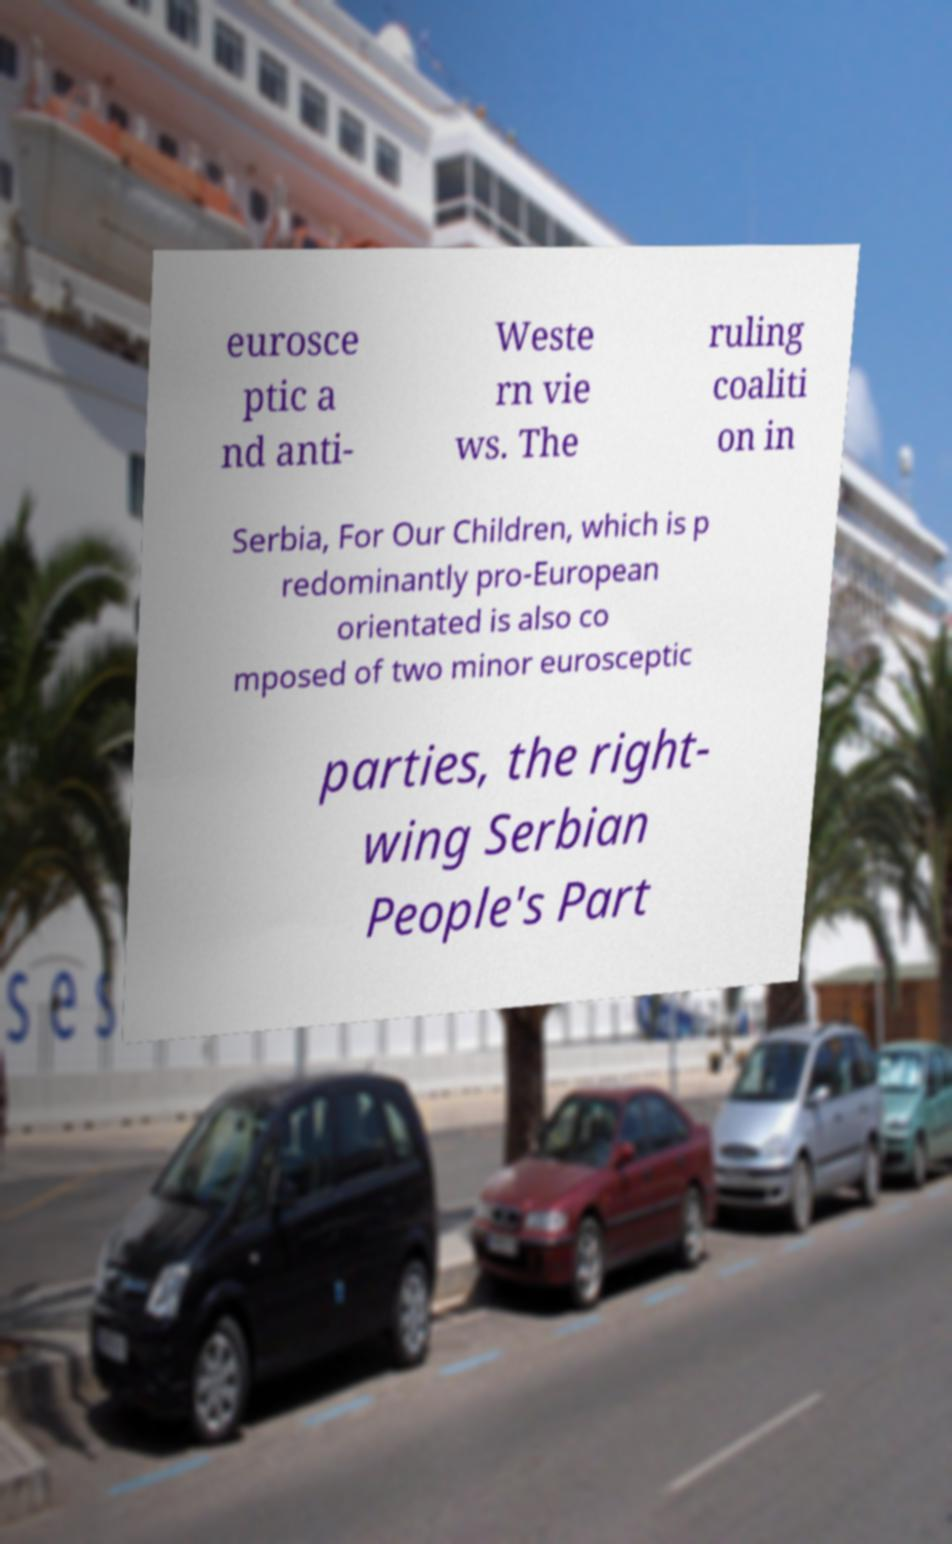Can you accurately transcribe the text from the provided image for me? eurosce ptic a nd anti- Weste rn vie ws. The ruling coaliti on in Serbia, For Our Children, which is p redominantly pro-European orientated is also co mposed of two minor eurosceptic parties, the right- wing Serbian People's Part 